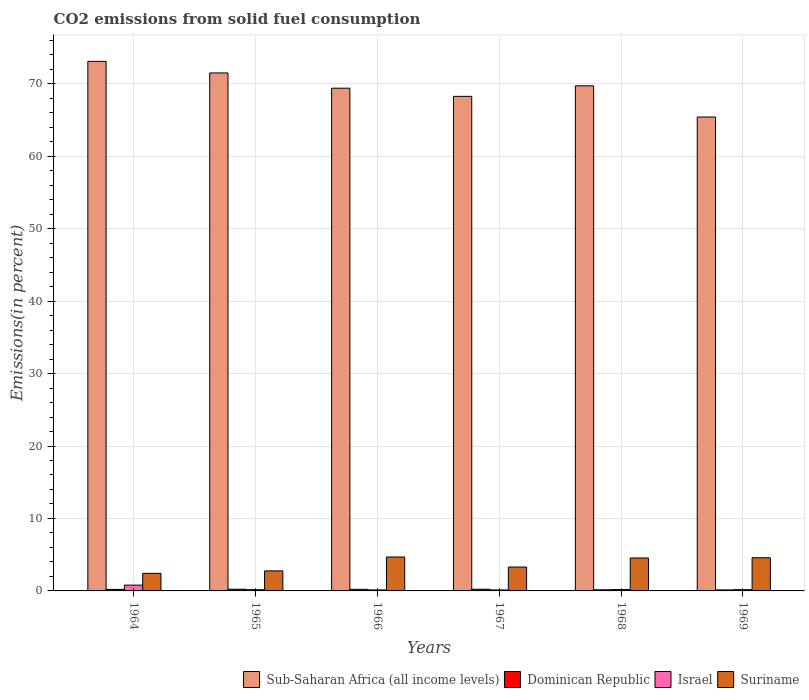Are the number of bars per tick equal to the number of legend labels?
Make the answer very short. Yes. Are the number of bars on each tick of the X-axis equal?
Ensure brevity in your answer.  Yes. How many bars are there on the 5th tick from the left?
Your answer should be very brief. 4. How many bars are there on the 4th tick from the right?
Make the answer very short. 4. What is the label of the 5th group of bars from the left?
Your response must be concise. 1968. What is the total CO2 emitted in Suriname in 1966?
Offer a very short reply. 4.68. Across all years, what is the maximum total CO2 emitted in Suriname?
Your answer should be compact. 4.68. Across all years, what is the minimum total CO2 emitted in Israel?
Your response must be concise. 0.13. In which year was the total CO2 emitted in Dominican Republic maximum?
Your answer should be compact. 1965. In which year was the total CO2 emitted in Israel minimum?
Your response must be concise. 1966. What is the total total CO2 emitted in Sub-Saharan Africa (all income levels) in the graph?
Your answer should be very brief. 417.33. What is the difference between the total CO2 emitted in Israel in 1966 and that in 1967?
Provide a succinct answer. -0. What is the difference between the total CO2 emitted in Dominican Republic in 1964 and the total CO2 emitted in Israel in 1967?
Ensure brevity in your answer.  0.07. What is the average total CO2 emitted in Dominican Republic per year?
Keep it short and to the point. 0.2. In the year 1965, what is the difference between the total CO2 emitted in Dominican Republic and total CO2 emitted in Sub-Saharan Africa (all income levels)?
Provide a short and direct response. -71.25. What is the ratio of the total CO2 emitted in Sub-Saharan Africa (all income levels) in 1966 to that in 1969?
Give a very brief answer. 1.06. What is the difference between the highest and the second highest total CO2 emitted in Israel?
Keep it short and to the point. 0.62. What is the difference between the highest and the lowest total CO2 emitted in Sub-Saharan Africa (all income levels)?
Provide a short and direct response. 7.68. Is the sum of the total CO2 emitted in Suriname in 1965 and 1967 greater than the maximum total CO2 emitted in Dominican Republic across all years?
Your answer should be compact. Yes. Is it the case that in every year, the sum of the total CO2 emitted in Suriname and total CO2 emitted in Israel is greater than the sum of total CO2 emitted in Dominican Republic and total CO2 emitted in Sub-Saharan Africa (all income levels)?
Keep it short and to the point. No. What does the 4th bar from the left in 1967 represents?
Give a very brief answer. Suriname. What does the 4th bar from the right in 1966 represents?
Keep it short and to the point. Sub-Saharan Africa (all income levels). Are all the bars in the graph horizontal?
Keep it short and to the point. No. What is the difference between two consecutive major ticks on the Y-axis?
Offer a terse response. 10. Are the values on the major ticks of Y-axis written in scientific E-notation?
Offer a very short reply. No. Does the graph contain any zero values?
Your response must be concise. No. Does the graph contain grids?
Your answer should be very brief. Yes. Where does the legend appear in the graph?
Make the answer very short. Bottom right. How many legend labels are there?
Your answer should be compact. 4. What is the title of the graph?
Offer a very short reply. CO2 emissions from solid fuel consumption. What is the label or title of the X-axis?
Offer a very short reply. Years. What is the label or title of the Y-axis?
Your answer should be compact. Emissions(in percent). What is the Emissions(in percent) of Sub-Saharan Africa (all income levels) in 1964?
Provide a short and direct response. 73.09. What is the Emissions(in percent) in Dominican Republic in 1964?
Give a very brief answer. 0.21. What is the Emissions(in percent) of Israel in 1964?
Offer a terse response. 0.8. What is the Emissions(in percent) of Suriname in 1964?
Give a very brief answer. 2.42. What is the Emissions(in percent) in Sub-Saharan Africa (all income levels) in 1965?
Your response must be concise. 71.49. What is the Emissions(in percent) of Dominican Republic in 1965?
Your response must be concise. 0.24. What is the Emissions(in percent) in Israel in 1965?
Your response must be concise. 0.17. What is the Emissions(in percent) in Suriname in 1965?
Your answer should be very brief. 2.76. What is the Emissions(in percent) of Sub-Saharan Africa (all income levels) in 1966?
Ensure brevity in your answer.  69.38. What is the Emissions(in percent) in Dominican Republic in 1966?
Your response must be concise. 0.22. What is the Emissions(in percent) of Israel in 1966?
Offer a very short reply. 0.13. What is the Emissions(in percent) in Suriname in 1966?
Keep it short and to the point. 4.68. What is the Emissions(in percent) in Sub-Saharan Africa (all income levels) in 1967?
Offer a terse response. 68.25. What is the Emissions(in percent) of Dominican Republic in 1967?
Provide a succinct answer. 0.23. What is the Emissions(in percent) in Israel in 1967?
Your response must be concise. 0.14. What is the Emissions(in percent) in Suriname in 1967?
Give a very brief answer. 3.3. What is the Emissions(in percent) in Sub-Saharan Africa (all income levels) in 1968?
Provide a succinct answer. 69.71. What is the Emissions(in percent) of Dominican Republic in 1968?
Give a very brief answer. 0.16. What is the Emissions(in percent) in Israel in 1968?
Provide a short and direct response. 0.19. What is the Emissions(in percent) of Suriname in 1968?
Provide a short and direct response. 4.55. What is the Emissions(in percent) of Sub-Saharan Africa (all income levels) in 1969?
Give a very brief answer. 65.4. What is the Emissions(in percent) of Dominican Republic in 1969?
Keep it short and to the point. 0.14. What is the Emissions(in percent) of Israel in 1969?
Your answer should be very brief. 0.17. What is the Emissions(in percent) in Suriname in 1969?
Give a very brief answer. 4.58. Across all years, what is the maximum Emissions(in percent) of Sub-Saharan Africa (all income levels)?
Your answer should be very brief. 73.09. Across all years, what is the maximum Emissions(in percent) of Dominican Republic?
Keep it short and to the point. 0.24. Across all years, what is the maximum Emissions(in percent) in Israel?
Give a very brief answer. 0.8. Across all years, what is the maximum Emissions(in percent) of Suriname?
Give a very brief answer. 4.68. Across all years, what is the minimum Emissions(in percent) of Sub-Saharan Africa (all income levels)?
Keep it short and to the point. 65.4. Across all years, what is the minimum Emissions(in percent) of Dominican Republic?
Your response must be concise. 0.14. Across all years, what is the minimum Emissions(in percent) in Israel?
Ensure brevity in your answer.  0.13. Across all years, what is the minimum Emissions(in percent) in Suriname?
Your answer should be very brief. 2.42. What is the total Emissions(in percent) of Sub-Saharan Africa (all income levels) in the graph?
Keep it short and to the point. 417.33. What is the total Emissions(in percent) in Dominican Republic in the graph?
Provide a succinct answer. 1.19. What is the total Emissions(in percent) in Israel in the graph?
Offer a very short reply. 1.6. What is the total Emissions(in percent) of Suriname in the graph?
Your answer should be compact. 22.29. What is the difference between the Emissions(in percent) in Sub-Saharan Africa (all income levels) in 1964 and that in 1965?
Ensure brevity in your answer.  1.6. What is the difference between the Emissions(in percent) of Dominican Republic in 1964 and that in 1965?
Give a very brief answer. -0.03. What is the difference between the Emissions(in percent) in Israel in 1964 and that in 1965?
Give a very brief answer. 0.63. What is the difference between the Emissions(in percent) of Suriname in 1964 and that in 1965?
Your response must be concise. -0.34. What is the difference between the Emissions(in percent) of Sub-Saharan Africa (all income levels) in 1964 and that in 1966?
Offer a very short reply. 3.71. What is the difference between the Emissions(in percent) of Dominican Republic in 1964 and that in 1966?
Provide a short and direct response. -0.01. What is the difference between the Emissions(in percent) of Israel in 1964 and that in 1966?
Give a very brief answer. 0.67. What is the difference between the Emissions(in percent) of Suriname in 1964 and that in 1966?
Keep it short and to the point. -2.26. What is the difference between the Emissions(in percent) in Sub-Saharan Africa (all income levels) in 1964 and that in 1967?
Offer a terse response. 4.83. What is the difference between the Emissions(in percent) in Dominican Republic in 1964 and that in 1967?
Provide a succinct answer. -0.02. What is the difference between the Emissions(in percent) in Israel in 1964 and that in 1967?
Your answer should be compact. 0.67. What is the difference between the Emissions(in percent) in Suriname in 1964 and that in 1967?
Ensure brevity in your answer.  -0.87. What is the difference between the Emissions(in percent) in Sub-Saharan Africa (all income levels) in 1964 and that in 1968?
Offer a terse response. 3.37. What is the difference between the Emissions(in percent) in Dominican Republic in 1964 and that in 1968?
Your answer should be compact. 0.05. What is the difference between the Emissions(in percent) in Israel in 1964 and that in 1968?
Keep it short and to the point. 0.62. What is the difference between the Emissions(in percent) of Suriname in 1964 and that in 1968?
Make the answer very short. -2.12. What is the difference between the Emissions(in percent) of Sub-Saharan Africa (all income levels) in 1964 and that in 1969?
Offer a terse response. 7.68. What is the difference between the Emissions(in percent) of Dominican Republic in 1964 and that in 1969?
Offer a very short reply. 0.07. What is the difference between the Emissions(in percent) in Israel in 1964 and that in 1969?
Provide a short and direct response. 0.63. What is the difference between the Emissions(in percent) of Suriname in 1964 and that in 1969?
Offer a terse response. -2.15. What is the difference between the Emissions(in percent) in Sub-Saharan Africa (all income levels) in 1965 and that in 1966?
Make the answer very short. 2.11. What is the difference between the Emissions(in percent) in Dominican Republic in 1965 and that in 1966?
Provide a succinct answer. 0.02. What is the difference between the Emissions(in percent) of Israel in 1965 and that in 1966?
Your answer should be compact. 0.04. What is the difference between the Emissions(in percent) of Suriname in 1965 and that in 1966?
Offer a very short reply. -1.92. What is the difference between the Emissions(in percent) in Sub-Saharan Africa (all income levels) in 1965 and that in 1967?
Keep it short and to the point. 3.23. What is the difference between the Emissions(in percent) of Dominican Republic in 1965 and that in 1967?
Provide a short and direct response. 0. What is the difference between the Emissions(in percent) of Israel in 1965 and that in 1967?
Your answer should be compact. 0.03. What is the difference between the Emissions(in percent) in Suriname in 1965 and that in 1967?
Offer a very short reply. -0.53. What is the difference between the Emissions(in percent) in Sub-Saharan Africa (all income levels) in 1965 and that in 1968?
Give a very brief answer. 1.77. What is the difference between the Emissions(in percent) in Dominican Republic in 1965 and that in 1968?
Make the answer very short. 0.08. What is the difference between the Emissions(in percent) of Israel in 1965 and that in 1968?
Your answer should be very brief. -0.02. What is the difference between the Emissions(in percent) in Suriname in 1965 and that in 1968?
Ensure brevity in your answer.  -1.78. What is the difference between the Emissions(in percent) of Sub-Saharan Africa (all income levels) in 1965 and that in 1969?
Your answer should be compact. 6.08. What is the difference between the Emissions(in percent) in Dominican Republic in 1965 and that in 1969?
Your answer should be very brief. 0.1. What is the difference between the Emissions(in percent) of Israel in 1965 and that in 1969?
Your answer should be compact. -0. What is the difference between the Emissions(in percent) in Suriname in 1965 and that in 1969?
Your answer should be very brief. -1.81. What is the difference between the Emissions(in percent) in Sub-Saharan Africa (all income levels) in 1966 and that in 1967?
Provide a succinct answer. 1.13. What is the difference between the Emissions(in percent) in Dominican Republic in 1966 and that in 1967?
Ensure brevity in your answer.  -0.01. What is the difference between the Emissions(in percent) in Israel in 1966 and that in 1967?
Provide a succinct answer. -0. What is the difference between the Emissions(in percent) in Suriname in 1966 and that in 1967?
Offer a terse response. 1.39. What is the difference between the Emissions(in percent) of Sub-Saharan Africa (all income levels) in 1966 and that in 1968?
Provide a succinct answer. -0.33. What is the difference between the Emissions(in percent) in Dominican Republic in 1966 and that in 1968?
Ensure brevity in your answer.  0.06. What is the difference between the Emissions(in percent) in Israel in 1966 and that in 1968?
Your answer should be compact. -0.05. What is the difference between the Emissions(in percent) in Suriname in 1966 and that in 1968?
Provide a short and direct response. 0.14. What is the difference between the Emissions(in percent) in Sub-Saharan Africa (all income levels) in 1966 and that in 1969?
Offer a very short reply. 3.98. What is the difference between the Emissions(in percent) in Dominican Republic in 1966 and that in 1969?
Offer a very short reply. 0.08. What is the difference between the Emissions(in percent) in Israel in 1966 and that in 1969?
Ensure brevity in your answer.  -0.04. What is the difference between the Emissions(in percent) of Suriname in 1966 and that in 1969?
Your answer should be compact. 0.1. What is the difference between the Emissions(in percent) of Sub-Saharan Africa (all income levels) in 1967 and that in 1968?
Your response must be concise. -1.46. What is the difference between the Emissions(in percent) in Dominican Republic in 1967 and that in 1968?
Your answer should be very brief. 0.08. What is the difference between the Emissions(in percent) of Israel in 1967 and that in 1968?
Make the answer very short. -0.05. What is the difference between the Emissions(in percent) in Suriname in 1967 and that in 1968?
Your answer should be compact. -1.25. What is the difference between the Emissions(in percent) of Sub-Saharan Africa (all income levels) in 1967 and that in 1969?
Offer a very short reply. 2.85. What is the difference between the Emissions(in percent) in Dominican Republic in 1967 and that in 1969?
Make the answer very short. 0.1. What is the difference between the Emissions(in percent) in Israel in 1967 and that in 1969?
Your response must be concise. -0.04. What is the difference between the Emissions(in percent) of Suriname in 1967 and that in 1969?
Offer a terse response. -1.28. What is the difference between the Emissions(in percent) of Sub-Saharan Africa (all income levels) in 1968 and that in 1969?
Give a very brief answer. 4.31. What is the difference between the Emissions(in percent) of Dominican Republic in 1968 and that in 1969?
Keep it short and to the point. 0.02. What is the difference between the Emissions(in percent) of Israel in 1968 and that in 1969?
Give a very brief answer. 0.01. What is the difference between the Emissions(in percent) of Suriname in 1968 and that in 1969?
Offer a very short reply. -0.03. What is the difference between the Emissions(in percent) of Sub-Saharan Africa (all income levels) in 1964 and the Emissions(in percent) of Dominican Republic in 1965?
Your response must be concise. 72.85. What is the difference between the Emissions(in percent) of Sub-Saharan Africa (all income levels) in 1964 and the Emissions(in percent) of Israel in 1965?
Your answer should be very brief. 72.92. What is the difference between the Emissions(in percent) in Sub-Saharan Africa (all income levels) in 1964 and the Emissions(in percent) in Suriname in 1965?
Your answer should be very brief. 70.32. What is the difference between the Emissions(in percent) of Dominican Republic in 1964 and the Emissions(in percent) of Israel in 1965?
Make the answer very short. 0.04. What is the difference between the Emissions(in percent) of Dominican Republic in 1964 and the Emissions(in percent) of Suriname in 1965?
Ensure brevity in your answer.  -2.56. What is the difference between the Emissions(in percent) in Israel in 1964 and the Emissions(in percent) in Suriname in 1965?
Keep it short and to the point. -1.96. What is the difference between the Emissions(in percent) of Sub-Saharan Africa (all income levels) in 1964 and the Emissions(in percent) of Dominican Republic in 1966?
Provide a short and direct response. 72.87. What is the difference between the Emissions(in percent) of Sub-Saharan Africa (all income levels) in 1964 and the Emissions(in percent) of Israel in 1966?
Provide a succinct answer. 72.95. What is the difference between the Emissions(in percent) of Sub-Saharan Africa (all income levels) in 1964 and the Emissions(in percent) of Suriname in 1966?
Your response must be concise. 68.4. What is the difference between the Emissions(in percent) in Dominican Republic in 1964 and the Emissions(in percent) in Israel in 1966?
Your answer should be very brief. 0.07. What is the difference between the Emissions(in percent) of Dominican Republic in 1964 and the Emissions(in percent) of Suriname in 1966?
Provide a succinct answer. -4.47. What is the difference between the Emissions(in percent) in Israel in 1964 and the Emissions(in percent) in Suriname in 1966?
Keep it short and to the point. -3.88. What is the difference between the Emissions(in percent) of Sub-Saharan Africa (all income levels) in 1964 and the Emissions(in percent) of Dominican Republic in 1967?
Ensure brevity in your answer.  72.85. What is the difference between the Emissions(in percent) of Sub-Saharan Africa (all income levels) in 1964 and the Emissions(in percent) of Israel in 1967?
Make the answer very short. 72.95. What is the difference between the Emissions(in percent) in Sub-Saharan Africa (all income levels) in 1964 and the Emissions(in percent) in Suriname in 1967?
Provide a succinct answer. 69.79. What is the difference between the Emissions(in percent) of Dominican Republic in 1964 and the Emissions(in percent) of Israel in 1967?
Your response must be concise. 0.07. What is the difference between the Emissions(in percent) of Dominican Republic in 1964 and the Emissions(in percent) of Suriname in 1967?
Make the answer very short. -3.09. What is the difference between the Emissions(in percent) in Israel in 1964 and the Emissions(in percent) in Suriname in 1967?
Provide a short and direct response. -2.5. What is the difference between the Emissions(in percent) of Sub-Saharan Africa (all income levels) in 1964 and the Emissions(in percent) of Dominican Republic in 1968?
Provide a short and direct response. 72.93. What is the difference between the Emissions(in percent) in Sub-Saharan Africa (all income levels) in 1964 and the Emissions(in percent) in Israel in 1968?
Keep it short and to the point. 72.9. What is the difference between the Emissions(in percent) in Sub-Saharan Africa (all income levels) in 1964 and the Emissions(in percent) in Suriname in 1968?
Provide a succinct answer. 68.54. What is the difference between the Emissions(in percent) of Dominican Republic in 1964 and the Emissions(in percent) of Israel in 1968?
Keep it short and to the point. 0.02. What is the difference between the Emissions(in percent) of Dominican Republic in 1964 and the Emissions(in percent) of Suriname in 1968?
Keep it short and to the point. -4.34. What is the difference between the Emissions(in percent) of Israel in 1964 and the Emissions(in percent) of Suriname in 1968?
Offer a terse response. -3.74. What is the difference between the Emissions(in percent) in Sub-Saharan Africa (all income levels) in 1964 and the Emissions(in percent) in Dominican Republic in 1969?
Your answer should be compact. 72.95. What is the difference between the Emissions(in percent) in Sub-Saharan Africa (all income levels) in 1964 and the Emissions(in percent) in Israel in 1969?
Offer a very short reply. 72.91. What is the difference between the Emissions(in percent) of Sub-Saharan Africa (all income levels) in 1964 and the Emissions(in percent) of Suriname in 1969?
Offer a very short reply. 68.51. What is the difference between the Emissions(in percent) of Dominican Republic in 1964 and the Emissions(in percent) of Israel in 1969?
Your response must be concise. 0.04. What is the difference between the Emissions(in percent) of Dominican Republic in 1964 and the Emissions(in percent) of Suriname in 1969?
Provide a short and direct response. -4.37. What is the difference between the Emissions(in percent) in Israel in 1964 and the Emissions(in percent) in Suriname in 1969?
Provide a succinct answer. -3.78. What is the difference between the Emissions(in percent) in Sub-Saharan Africa (all income levels) in 1965 and the Emissions(in percent) in Dominican Republic in 1966?
Your answer should be compact. 71.27. What is the difference between the Emissions(in percent) in Sub-Saharan Africa (all income levels) in 1965 and the Emissions(in percent) in Israel in 1966?
Provide a short and direct response. 71.35. What is the difference between the Emissions(in percent) in Sub-Saharan Africa (all income levels) in 1965 and the Emissions(in percent) in Suriname in 1966?
Ensure brevity in your answer.  66.8. What is the difference between the Emissions(in percent) in Dominican Republic in 1965 and the Emissions(in percent) in Israel in 1966?
Provide a short and direct response. 0.1. What is the difference between the Emissions(in percent) in Dominican Republic in 1965 and the Emissions(in percent) in Suriname in 1966?
Your answer should be compact. -4.45. What is the difference between the Emissions(in percent) in Israel in 1965 and the Emissions(in percent) in Suriname in 1966?
Keep it short and to the point. -4.51. What is the difference between the Emissions(in percent) in Sub-Saharan Africa (all income levels) in 1965 and the Emissions(in percent) in Dominican Republic in 1967?
Your answer should be compact. 71.25. What is the difference between the Emissions(in percent) in Sub-Saharan Africa (all income levels) in 1965 and the Emissions(in percent) in Israel in 1967?
Your response must be concise. 71.35. What is the difference between the Emissions(in percent) in Sub-Saharan Africa (all income levels) in 1965 and the Emissions(in percent) in Suriname in 1967?
Keep it short and to the point. 68.19. What is the difference between the Emissions(in percent) in Dominican Republic in 1965 and the Emissions(in percent) in Israel in 1967?
Keep it short and to the point. 0.1. What is the difference between the Emissions(in percent) of Dominican Republic in 1965 and the Emissions(in percent) of Suriname in 1967?
Make the answer very short. -3.06. What is the difference between the Emissions(in percent) in Israel in 1965 and the Emissions(in percent) in Suriname in 1967?
Ensure brevity in your answer.  -3.13. What is the difference between the Emissions(in percent) in Sub-Saharan Africa (all income levels) in 1965 and the Emissions(in percent) in Dominican Republic in 1968?
Offer a very short reply. 71.33. What is the difference between the Emissions(in percent) in Sub-Saharan Africa (all income levels) in 1965 and the Emissions(in percent) in Israel in 1968?
Ensure brevity in your answer.  71.3. What is the difference between the Emissions(in percent) of Sub-Saharan Africa (all income levels) in 1965 and the Emissions(in percent) of Suriname in 1968?
Give a very brief answer. 66.94. What is the difference between the Emissions(in percent) in Dominican Republic in 1965 and the Emissions(in percent) in Israel in 1968?
Provide a short and direct response. 0.05. What is the difference between the Emissions(in percent) of Dominican Republic in 1965 and the Emissions(in percent) of Suriname in 1968?
Your answer should be compact. -4.31. What is the difference between the Emissions(in percent) of Israel in 1965 and the Emissions(in percent) of Suriname in 1968?
Your answer should be very brief. -4.38. What is the difference between the Emissions(in percent) of Sub-Saharan Africa (all income levels) in 1965 and the Emissions(in percent) of Dominican Republic in 1969?
Your response must be concise. 71.35. What is the difference between the Emissions(in percent) of Sub-Saharan Africa (all income levels) in 1965 and the Emissions(in percent) of Israel in 1969?
Offer a terse response. 71.31. What is the difference between the Emissions(in percent) of Sub-Saharan Africa (all income levels) in 1965 and the Emissions(in percent) of Suriname in 1969?
Ensure brevity in your answer.  66.91. What is the difference between the Emissions(in percent) in Dominican Republic in 1965 and the Emissions(in percent) in Israel in 1969?
Make the answer very short. 0.06. What is the difference between the Emissions(in percent) of Dominican Republic in 1965 and the Emissions(in percent) of Suriname in 1969?
Make the answer very short. -4.34. What is the difference between the Emissions(in percent) in Israel in 1965 and the Emissions(in percent) in Suriname in 1969?
Offer a very short reply. -4.41. What is the difference between the Emissions(in percent) of Sub-Saharan Africa (all income levels) in 1966 and the Emissions(in percent) of Dominican Republic in 1967?
Offer a terse response. 69.15. What is the difference between the Emissions(in percent) of Sub-Saharan Africa (all income levels) in 1966 and the Emissions(in percent) of Israel in 1967?
Make the answer very short. 69.25. What is the difference between the Emissions(in percent) in Sub-Saharan Africa (all income levels) in 1966 and the Emissions(in percent) in Suriname in 1967?
Make the answer very short. 66.08. What is the difference between the Emissions(in percent) in Dominican Republic in 1966 and the Emissions(in percent) in Israel in 1967?
Offer a terse response. 0.08. What is the difference between the Emissions(in percent) in Dominican Republic in 1966 and the Emissions(in percent) in Suriname in 1967?
Your response must be concise. -3.08. What is the difference between the Emissions(in percent) in Israel in 1966 and the Emissions(in percent) in Suriname in 1967?
Provide a short and direct response. -3.16. What is the difference between the Emissions(in percent) in Sub-Saharan Africa (all income levels) in 1966 and the Emissions(in percent) in Dominican Republic in 1968?
Provide a succinct answer. 69.23. What is the difference between the Emissions(in percent) of Sub-Saharan Africa (all income levels) in 1966 and the Emissions(in percent) of Israel in 1968?
Provide a succinct answer. 69.2. What is the difference between the Emissions(in percent) in Sub-Saharan Africa (all income levels) in 1966 and the Emissions(in percent) in Suriname in 1968?
Offer a very short reply. 64.84. What is the difference between the Emissions(in percent) in Dominican Republic in 1966 and the Emissions(in percent) in Israel in 1968?
Your response must be concise. 0.03. What is the difference between the Emissions(in percent) of Dominican Republic in 1966 and the Emissions(in percent) of Suriname in 1968?
Make the answer very short. -4.33. What is the difference between the Emissions(in percent) of Israel in 1966 and the Emissions(in percent) of Suriname in 1968?
Offer a very short reply. -4.41. What is the difference between the Emissions(in percent) in Sub-Saharan Africa (all income levels) in 1966 and the Emissions(in percent) in Dominican Republic in 1969?
Offer a terse response. 69.24. What is the difference between the Emissions(in percent) in Sub-Saharan Africa (all income levels) in 1966 and the Emissions(in percent) in Israel in 1969?
Provide a succinct answer. 69.21. What is the difference between the Emissions(in percent) in Sub-Saharan Africa (all income levels) in 1966 and the Emissions(in percent) in Suriname in 1969?
Offer a very short reply. 64.8. What is the difference between the Emissions(in percent) in Dominican Republic in 1966 and the Emissions(in percent) in Israel in 1969?
Offer a very short reply. 0.05. What is the difference between the Emissions(in percent) in Dominican Republic in 1966 and the Emissions(in percent) in Suriname in 1969?
Your response must be concise. -4.36. What is the difference between the Emissions(in percent) of Israel in 1966 and the Emissions(in percent) of Suriname in 1969?
Keep it short and to the point. -4.44. What is the difference between the Emissions(in percent) in Sub-Saharan Africa (all income levels) in 1967 and the Emissions(in percent) in Dominican Republic in 1968?
Give a very brief answer. 68.1. What is the difference between the Emissions(in percent) of Sub-Saharan Africa (all income levels) in 1967 and the Emissions(in percent) of Israel in 1968?
Offer a terse response. 68.07. What is the difference between the Emissions(in percent) in Sub-Saharan Africa (all income levels) in 1967 and the Emissions(in percent) in Suriname in 1968?
Your answer should be very brief. 63.71. What is the difference between the Emissions(in percent) of Dominican Republic in 1967 and the Emissions(in percent) of Israel in 1968?
Your response must be concise. 0.05. What is the difference between the Emissions(in percent) in Dominican Republic in 1967 and the Emissions(in percent) in Suriname in 1968?
Ensure brevity in your answer.  -4.31. What is the difference between the Emissions(in percent) of Israel in 1967 and the Emissions(in percent) of Suriname in 1968?
Your answer should be compact. -4.41. What is the difference between the Emissions(in percent) in Sub-Saharan Africa (all income levels) in 1967 and the Emissions(in percent) in Dominican Republic in 1969?
Provide a short and direct response. 68.12. What is the difference between the Emissions(in percent) of Sub-Saharan Africa (all income levels) in 1967 and the Emissions(in percent) of Israel in 1969?
Make the answer very short. 68.08. What is the difference between the Emissions(in percent) in Sub-Saharan Africa (all income levels) in 1967 and the Emissions(in percent) in Suriname in 1969?
Make the answer very short. 63.68. What is the difference between the Emissions(in percent) of Dominican Republic in 1967 and the Emissions(in percent) of Israel in 1969?
Offer a very short reply. 0.06. What is the difference between the Emissions(in percent) of Dominican Republic in 1967 and the Emissions(in percent) of Suriname in 1969?
Give a very brief answer. -4.34. What is the difference between the Emissions(in percent) of Israel in 1967 and the Emissions(in percent) of Suriname in 1969?
Make the answer very short. -4.44. What is the difference between the Emissions(in percent) in Sub-Saharan Africa (all income levels) in 1968 and the Emissions(in percent) in Dominican Republic in 1969?
Ensure brevity in your answer.  69.57. What is the difference between the Emissions(in percent) in Sub-Saharan Africa (all income levels) in 1968 and the Emissions(in percent) in Israel in 1969?
Offer a terse response. 69.54. What is the difference between the Emissions(in percent) of Sub-Saharan Africa (all income levels) in 1968 and the Emissions(in percent) of Suriname in 1969?
Keep it short and to the point. 65.13. What is the difference between the Emissions(in percent) in Dominican Republic in 1968 and the Emissions(in percent) in Israel in 1969?
Give a very brief answer. -0.02. What is the difference between the Emissions(in percent) of Dominican Republic in 1968 and the Emissions(in percent) of Suriname in 1969?
Give a very brief answer. -4.42. What is the difference between the Emissions(in percent) in Israel in 1968 and the Emissions(in percent) in Suriname in 1969?
Your answer should be very brief. -4.39. What is the average Emissions(in percent) of Sub-Saharan Africa (all income levels) per year?
Your response must be concise. 69.55. What is the average Emissions(in percent) in Dominican Republic per year?
Provide a short and direct response. 0.2. What is the average Emissions(in percent) of Israel per year?
Your answer should be compact. 0.27. What is the average Emissions(in percent) of Suriname per year?
Ensure brevity in your answer.  3.72. In the year 1964, what is the difference between the Emissions(in percent) in Sub-Saharan Africa (all income levels) and Emissions(in percent) in Dominican Republic?
Your answer should be compact. 72.88. In the year 1964, what is the difference between the Emissions(in percent) in Sub-Saharan Africa (all income levels) and Emissions(in percent) in Israel?
Your response must be concise. 72.28. In the year 1964, what is the difference between the Emissions(in percent) of Sub-Saharan Africa (all income levels) and Emissions(in percent) of Suriname?
Keep it short and to the point. 70.66. In the year 1964, what is the difference between the Emissions(in percent) in Dominican Republic and Emissions(in percent) in Israel?
Provide a succinct answer. -0.59. In the year 1964, what is the difference between the Emissions(in percent) in Dominican Republic and Emissions(in percent) in Suriname?
Your answer should be very brief. -2.21. In the year 1964, what is the difference between the Emissions(in percent) in Israel and Emissions(in percent) in Suriname?
Provide a succinct answer. -1.62. In the year 1965, what is the difference between the Emissions(in percent) of Sub-Saharan Africa (all income levels) and Emissions(in percent) of Dominican Republic?
Offer a terse response. 71.25. In the year 1965, what is the difference between the Emissions(in percent) in Sub-Saharan Africa (all income levels) and Emissions(in percent) in Israel?
Offer a very short reply. 71.32. In the year 1965, what is the difference between the Emissions(in percent) of Sub-Saharan Africa (all income levels) and Emissions(in percent) of Suriname?
Your answer should be very brief. 68.72. In the year 1965, what is the difference between the Emissions(in percent) in Dominican Republic and Emissions(in percent) in Israel?
Provide a short and direct response. 0.07. In the year 1965, what is the difference between the Emissions(in percent) of Dominican Republic and Emissions(in percent) of Suriname?
Offer a very short reply. -2.53. In the year 1965, what is the difference between the Emissions(in percent) in Israel and Emissions(in percent) in Suriname?
Ensure brevity in your answer.  -2.6. In the year 1966, what is the difference between the Emissions(in percent) in Sub-Saharan Africa (all income levels) and Emissions(in percent) in Dominican Republic?
Make the answer very short. 69.16. In the year 1966, what is the difference between the Emissions(in percent) of Sub-Saharan Africa (all income levels) and Emissions(in percent) of Israel?
Your answer should be compact. 69.25. In the year 1966, what is the difference between the Emissions(in percent) of Sub-Saharan Africa (all income levels) and Emissions(in percent) of Suriname?
Your response must be concise. 64.7. In the year 1966, what is the difference between the Emissions(in percent) in Dominican Republic and Emissions(in percent) in Israel?
Your answer should be compact. 0.08. In the year 1966, what is the difference between the Emissions(in percent) in Dominican Republic and Emissions(in percent) in Suriname?
Provide a short and direct response. -4.46. In the year 1966, what is the difference between the Emissions(in percent) of Israel and Emissions(in percent) of Suriname?
Give a very brief answer. -4.55. In the year 1967, what is the difference between the Emissions(in percent) of Sub-Saharan Africa (all income levels) and Emissions(in percent) of Dominican Republic?
Give a very brief answer. 68.02. In the year 1967, what is the difference between the Emissions(in percent) in Sub-Saharan Africa (all income levels) and Emissions(in percent) in Israel?
Keep it short and to the point. 68.12. In the year 1967, what is the difference between the Emissions(in percent) of Sub-Saharan Africa (all income levels) and Emissions(in percent) of Suriname?
Make the answer very short. 64.96. In the year 1967, what is the difference between the Emissions(in percent) in Dominican Republic and Emissions(in percent) in Israel?
Provide a short and direct response. 0.1. In the year 1967, what is the difference between the Emissions(in percent) in Dominican Republic and Emissions(in percent) in Suriname?
Your answer should be compact. -3.06. In the year 1967, what is the difference between the Emissions(in percent) of Israel and Emissions(in percent) of Suriname?
Give a very brief answer. -3.16. In the year 1968, what is the difference between the Emissions(in percent) in Sub-Saharan Africa (all income levels) and Emissions(in percent) in Dominican Republic?
Ensure brevity in your answer.  69.56. In the year 1968, what is the difference between the Emissions(in percent) of Sub-Saharan Africa (all income levels) and Emissions(in percent) of Israel?
Offer a very short reply. 69.53. In the year 1968, what is the difference between the Emissions(in percent) in Sub-Saharan Africa (all income levels) and Emissions(in percent) in Suriname?
Your response must be concise. 65.17. In the year 1968, what is the difference between the Emissions(in percent) of Dominican Republic and Emissions(in percent) of Israel?
Your response must be concise. -0.03. In the year 1968, what is the difference between the Emissions(in percent) of Dominican Republic and Emissions(in percent) of Suriname?
Ensure brevity in your answer.  -4.39. In the year 1968, what is the difference between the Emissions(in percent) in Israel and Emissions(in percent) in Suriname?
Offer a very short reply. -4.36. In the year 1969, what is the difference between the Emissions(in percent) in Sub-Saharan Africa (all income levels) and Emissions(in percent) in Dominican Republic?
Give a very brief answer. 65.27. In the year 1969, what is the difference between the Emissions(in percent) in Sub-Saharan Africa (all income levels) and Emissions(in percent) in Israel?
Give a very brief answer. 65.23. In the year 1969, what is the difference between the Emissions(in percent) of Sub-Saharan Africa (all income levels) and Emissions(in percent) of Suriname?
Offer a terse response. 60.83. In the year 1969, what is the difference between the Emissions(in percent) of Dominican Republic and Emissions(in percent) of Israel?
Offer a very short reply. -0.04. In the year 1969, what is the difference between the Emissions(in percent) of Dominican Republic and Emissions(in percent) of Suriname?
Make the answer very short. -4.44. In the year 1969, what is the difference between the Emissions(in percent) of Israel and Emissions(in percent) of Suriname?
Your answer should be compact. -4.41. What is the ratio of the Emissions(in percent) in Sub-Saharan Africa (all income levels) in 1964 to that in 1965?
Offer a terse response. 1.02. What is the ratio of the Emissions(in percent) in Dominican Republic in 1964 to that in 1965?
Your response must be concise. 0.88. What is the ratio of the Emissions(in percent) of Israel in 1964 to that in 1965?
Your response must be concise. 4.72. What is the ratio of the Emissions(in percent) of Suriname in 1964 to that in 1965?
Offer a very short reply. 0.88. What is the ratio of the Emissions(in percent) of Sub-Saharan Africa (all income levels) in 1964 to that in 1966?
Your response must be concise. 1.05. What is the ratio of the Emissions(in percent) of Dominican Republic in 1964 to that in 1966?
Offer a terse response. 0.96. What is the ratio of the Emissions(in percent) in Israel in 1964 to that in 1966?
Ensure brevity in your answer.  5.94. What is the ratio of the Emissions(in percent) in Suriname in 1964 to that in 1966?
Keep it short and to the point. 0.52. What is the ratio of the Emissions(in percent) in Sub-Saharan Africa (all income levels) in 1964 to that in 1967?
Your answer should be very brief. 1.07. What is the ratio of the Emissions(in percent) in Dominican Republic in 1964 to that in 1967?
Ensure brevity in your answer.  0.9. What is the ratio of the Emissions(in percent) in Israel in 1964 to that in 1967?
Ensure brevity in your answer.  5.92. What is the ratio of the Emissions(in percent) of Suriname in 1964 to that in 1967?
Give a very brief answer. 0.74. What is the ratio of the Emissions(in percent) in Sub-Saharan Africa (all income levels) in 1964 to that in 1968?
Keep it short and to the point. 1.05. What is the ratio of the Emissions(in percent) in Dominican Republic in 1964 to that in 1968?
Keep it short and to the point. 1.34. What is the ratio of the Emissions(in percent) of Israel in 1964 to that in 1968?
Provide a short and direct response. 4.31. What is the ratio of the Emissions(in percent) in Suriname in 1964 to that in 1968?
Your response must be concise. 0.53. What is the ratio of the Emissions(in percent) in Sub-Saharan Africa (all income levels) in 1964 to that in 1969?
Offer a very short reply. 1.12. What is the ratio of the Emissions(in percent) in Dominican Republic in 1964 to that in 1969?
Give a very brief answer. 1.52. What is the ratio of the Emissions(in percent) in Israel in 1964 to that in 1969?
Provide a short and direct response. 4.63. What is the ratio of the Emissions(in percent) in Suriname in 1964 to that in 1969?
Your response must be concise. 0.53. What is the ratio of the Emissions(in percent) in Sub-Saharan Africa (all income levels) in 1965 to that in 1966?
Your answer should be compact. 1.03. What is the ratio of the Emissions(in percent) of Dominican Republic in 1965 to that in 1966?
Your response must be concise. 1.08. What is the ratio of the Emissions(in percent) of Israel in 1965 to that in 1966?
Your answer should be compact. 1.26. What is the ratio of the Emissions(in percent) in Suriname in 1965 to that in 1966?
Your answer should be compact. 0.59. What is the ratio of the Emissions(in percent) of Sub-Saharan Africa (all income levels) in 1965 to that in 1967?
Your answer should be compact. 1.05. What is the ratio of the Emissions(in percent) of Dominican Republic in 1965 to that in 1967?
Ensure brevity in your answer.  1.01. What is the ratio of the Emissions(in percent) in Israel in 1965 to that in 1967?
Give a very brief answer. 1.26. What is the ratio of the Emissions(in percent) of Suriname in 1965 to that in 1967?
Provide a short and direct response. 0.84. What is the ratio of the Emissions(in percent) of Sub-Saharan Africa (all income levels) in 1965 to that in 1968?
Offer a terse response. 1.03. What is the ratio of the Emissions(in percent) of Dominican Republic in 1965 to that in 1968?
Offer a very short reply. 1.52. What is the ratio of the Emissions(in percent) in Israel in 1965 to that in 1968?
Ensure brevity in your answer.  0.91. What is the ratio of the Emissions(in percent) of Suriname in 1965 to that in 1968?
Your response must be concise. 0.61. What is the ratio of the Emissions(in percent) of Sub-Saharan Africa (all income levels) in 1965 to that in 1969?
Offer a very short reply. 1.09. What is the ratio of the Emissions(in percent) in Dominican Republic in 1965 to that in 1969?
Make the answer very short. 1.72. What is the ratio of the Emissions(in percent) in Israel in 1965 to that in 1969?
Ensure brevity in your answer.  0.98. What is the ratio of the Emissions(in percent) of Suriname in 1965 to that in 1969?
Offer a very short reply. 0.6. What is the ratio of the Emissions(in percent) of Sub-Saharan Africa (all income levels) in 1966 to that in 1967?
Offer a terse response. 1.02. What is the ratio of the Emissions(in percent) in Dominican Republic in 1966 to that in 1967?
Provide a short and direct response. 0.94. What is the ratio of the Emissions(in percent) in Suriname in 1966 to that in 1967?
Provide a succinct answer. 1.42. What is the ratio of the Emissions(in percent) of Dominican Republic in 1966 to that in 1968?
Make the answer very short. 1.41. What is the ratio of the Emissions(in percent) in Israel in 1966 to that in 1968?
Make the answer very short. 0.73. What is the ratio of the Emissions(in percent) of Suriname in 1966 to that in 1968?
Offer a terse response. 1.03. What is the ratio of the Emissions(in percent) in Sub-Saharan Africa (all income levels) in 1966 to that in 1969?
Keep it short and to the point. 1.06. What is the ratio of the Emissions(in percent) in Dominican Republic in 1966 to that in 1969?
Your answer should be compact. 1.59. What is the ratio of the Emissions(in percent) in Israel in 1966 to that in 1969?
Provide a succinct answer. 0.78. What is the ratio of the Emissions(in percent) in Suriname in 1966 to that in 1969?
Ensure brevity in your answer.  1.02. What is the ratio of the Emissions(in percent) of Sub-Saharan Africa (all income levels) in 1967 to that in 1968?
Keep it short and to the point. 0.98. What is the ratio of the Emissions(in percent) of Dominican Republic in 1967 to that in 1968?
Offer a terse response. 1.5. What is the ratio of the Emissions(in percent) in Israel in 1967 to that in 1968?
Make the answer very short. 0.73. What is the ratio of the Emissions(in percent) of Suriname in 1967 to that in 1968?
Your answer should be very brief. 0.73. What is the ratio of the Emissions(in percent) of Sub-Saharan Africa (all income levels) in 1967 to that in 1969?
Make the answer very short. 1.04. What is the ratio of the Emissions(in percent) of Dominican Republic in 1967 to that in 1969?
Your answer should be very brief. 1.69. What is the ratio of the Emissions(in percent) of Israel in 1967 to that in 1969?
Keep it short and to the point. 0.78. What is the ratio of the Emissions(in percent) in Suriname in 1967 to that in 1969?
Provide a succinct answer. 0.72. What is the ratio of the Emissions(in percent) in Sub-Saharan Africa (all income levels) in 1968 to that in 1969?
Provide a short and direct response. 1.07. What is the ratio of the Emissions(in percent) of Dominican Republic in 1968 to that in 1969?
Your answer should be compact. 1.13. What is the ratio of the Emissions(in percent) in Israel in 1968 to that in 1969?
Keep it short and to the point. 1.07. What is the difference between the highest and the second highest Emissions(in percent) in Sub-Saharan Africa (all income levels)?
Provide a short and direct response. 1.6. What is the difference between the highest and the second highest Emissions(in percent) in Dominican Republic?
Keep it short and to the point. 0. What is the difference between the highest and the second highest Emissions(in percent) of Israel?
Your answer should be compact. 0.62. What is the difference between the highest and the second highest Emissions(in percent) in Suriname?
Your response must be concise. 0.1. What is the difference between the highest and the lowest Emissions(in percent) of Sub-Saharan Africa (all income levels)?
Keep it short and to the point. 7.68. What is the difference between the highest and the lowest Emissions(in percent) of Dominican Republic?
Offer a very short reply. 0.1. What is the difference between the highest and the lowest Emissions(in percent) of Israel?
Your answer should be very brief. 0.67. What is the difference between the highest and the lowest Emissions(in percent) in Suriname?
Ensure brevity in your answer.  2.26. 